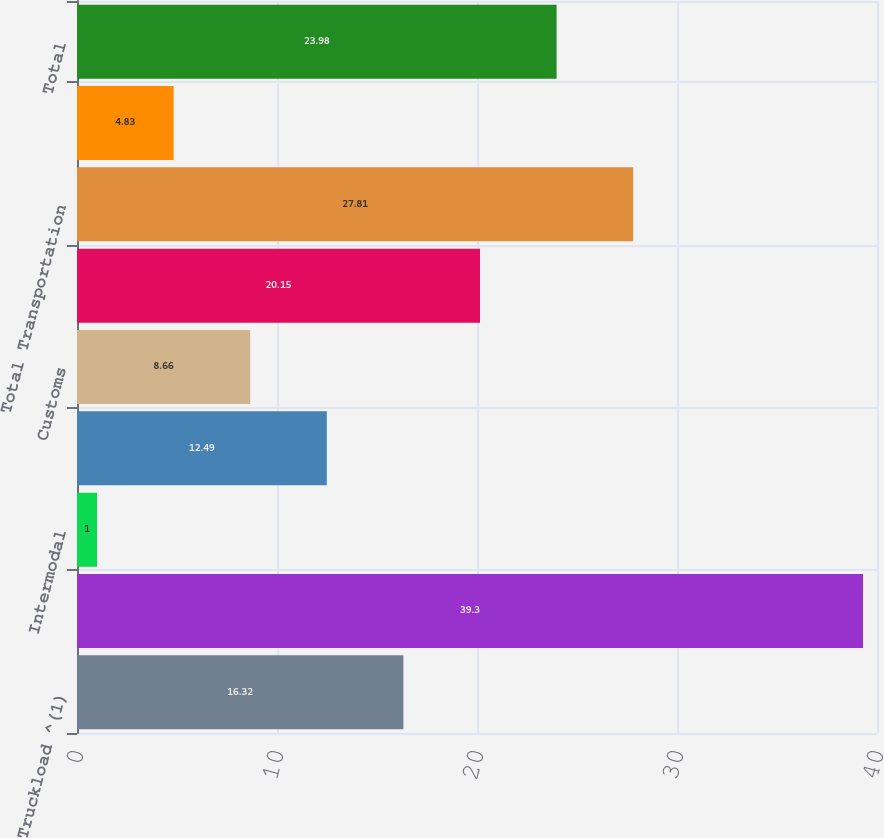<chart> <loc_0><loc_0><loc_500><loc_500><bar_chart><fcel>Truckload ^(1)<fcel>LTL (2)<fcel>Intermodal<fcel>Ocean<fcel>Customs<fcel>Other Logistics Services<fcel>Total Transportation<fcel>Sourcing<fcel>Total<nl><fcel>16.32<fcel>39.3<fcel>1<fcel>12.49<fcel>8.66<fcel>20.15<fcel>27.81<fcel>4.83<fcel>23.98<nl></chart> 